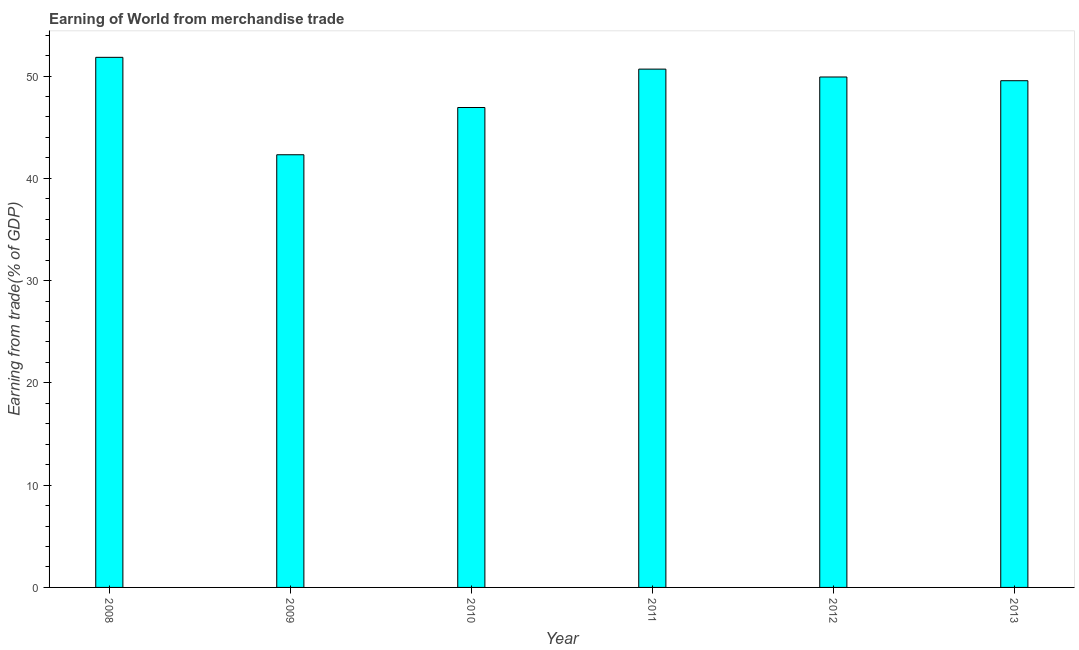Does the graph contain any zero values?
Provide a succinct answer. No. What is the title of the graph?
Keep it short and to the point. Earning of World from merchandise trade. What is the label or title of the Y-axis?
Provide a succinct answer. Earning from trade(% of GDP). What is the earning from merchandise trade in 2013?
Make the answer very short. 49.54. Across all years, what is the maximum earning from merchandise trade?
Your response must be concise. 51.83. Across all years, what is the minimum earning from merchandise trade?
Your answer should be compact. 42.3. What is the sum of the earning from merchandise trade?
Give a very brief answer. 291.18. What is the difference between the earning from merchandise trade in 2010 and 2012?
Your answer should be compact. -2.98. What is the average earning from merchandise trade per year?
Give a very brief answer. 48.53. What is the median earning from merchandise trade?
Give a very brief answer. 49.72. Do a majority of the years between 2008 and 2011 (inclusive) have earning from merchandise trade greater than 32 %?
Make the answer very short. Yes. Is the difference between the earning from merchandise trade in 2009 and 2012 greater than the difference between any two years?
Your response must be concise. No. What is the difference between the highest and the second highest earning from merchandise trade?
Make the answer very short. 1.15. What is the difference between the highest and the lowest earning from merchandise trade?
Give a very brief answer. 9.53. How many years are there in the graph?
Ensure brevity in your answer.  6. Are the values on the major ticks of Y-axis written in scientific E-notation?
Keep it short and to the point. No. What is the Earning from trade(% of GDP) of 2008?
Offer a terse response. 51.83. What is the Earning from trade(% of GDP) of 2009?
Make the answer very short. 42.3. What is the Earning from trade(% of GDP) of 2010?
Your answer should be very brief. 46.92. What is the Earning from trade(% of GDP) in 2011?
Your answer should be very brief. 50.68. What is the Earning from trade(% of GDP) in 2012?
Offer a very short reply. 49.91. What is the Earning from trade(% of GDP) of 2013?
Provide a succinct answer. 49.54. What is the difference between the Earning from trade(% of GDP) in 2008 and 2009?
Keep it short and to the point. 9.53. What is the difference between the Earning from trade(% of GDP) in 2008 and 2010?
Your answer should be very brief. 4.91. What is the difference between the Earning from trade(% of GDP) in 2008 and 2011?
Your answer should be very brief. 1.15. What is the difference between the Earning from trade(% of GDP) in 2008 and 2012?
Your response must be concise. 1.92. What is the difference between the Earning from trade(% of GDP) in 2008 and 2013?
Give a very brief answer. 2.29. What is the difference between the Earning from trade(% of GDP) in 2009 and 2010?
Your response must be concise. -4.62. What is the difference between the Earning from trade(% of GDP) in 2009 and 2011?
Make the answer very short. -8.37. What is the difference between the Earning from trade(% of GDP) in 2009 and 2012?
Keep it short and to the point. -7.6. What is the difference between the Earning from trade(% of GDP) in 2009 and 2013?
Provide a short and direct response. -7.24. What is the difference between the Earning from trade(% of GDP) in 2010 and 2011?
Offer a terse response. -3.75. What is the difference between the Earning from trade(% of GDP) in 2010 and 2012?
Provide a succinct answer. -2.98. What is the difference between the Earning from trade(% of GDP) in 2010 and 2013?
Ensure brevity in your answer.  -2.62. What is the difference between the Earning from trade(% of GDP) in 2011 and 2012?
Your answer should be compact. 0.77. What is the difference between the Earning from trade(% of GDP) in 2011 and 2013?
Offer a very short reply. 1.13. What is the difference between the Earning from trade(% of GDP) in 2012 and 2013?
Provide a succinct answer. 0.36. What is the ratio of the Earning from trade(% of GDP) in 2008 to that in 2009?
Your response must be concise. 1.23. What is the ratio of the Earning from trade(% of GDP) in 2008 to that in 2010?
Offer a very short reply. 1.1. What is the ratio of the Earning from trade(% of GDP) in 2008 to that in 2012?
Offer a terse response. 1.04. What is the ratio of the Earning from trade(% of GDP) in 2008 to that in 2013?
Ensure brevity in your answer.  1.05. What is the ratio of the Earning from trade(% of GDP) in 2009 to that in 2010?
Offer a terse response. 0.9. What is the ratio of the Earning from trade(% of GDP) in 2009 to that in 2011?
Provide a short and direct response. 0.83. What is the ratio of the Earning from trade(% of GDP) in 2009 to that in 2012?
Offer a terse response. 0.85. What is the ratio of the Earning from trade(% of GDP) in 2009 to that in 2013?
Provide a short and direct response. 0.85. What is the ratio of the Earning from trade(% of GDP) in 2010 to that in 2011?
Your answer should be compact. 0.93. What is the ratio of the Earning from trade(% of GDP) in 2010 to that in 2012?
Provide a short and direct response. 0.94. What is the ratio of the Earning from trade(% of GDP) in 2010 to that in 2013?
Offer a very short reply. 0.95. What is the ratio of the Earning from trade(% of GDP) in 2011 to that in 2013?
Keep it short and to the point. 1.02. 